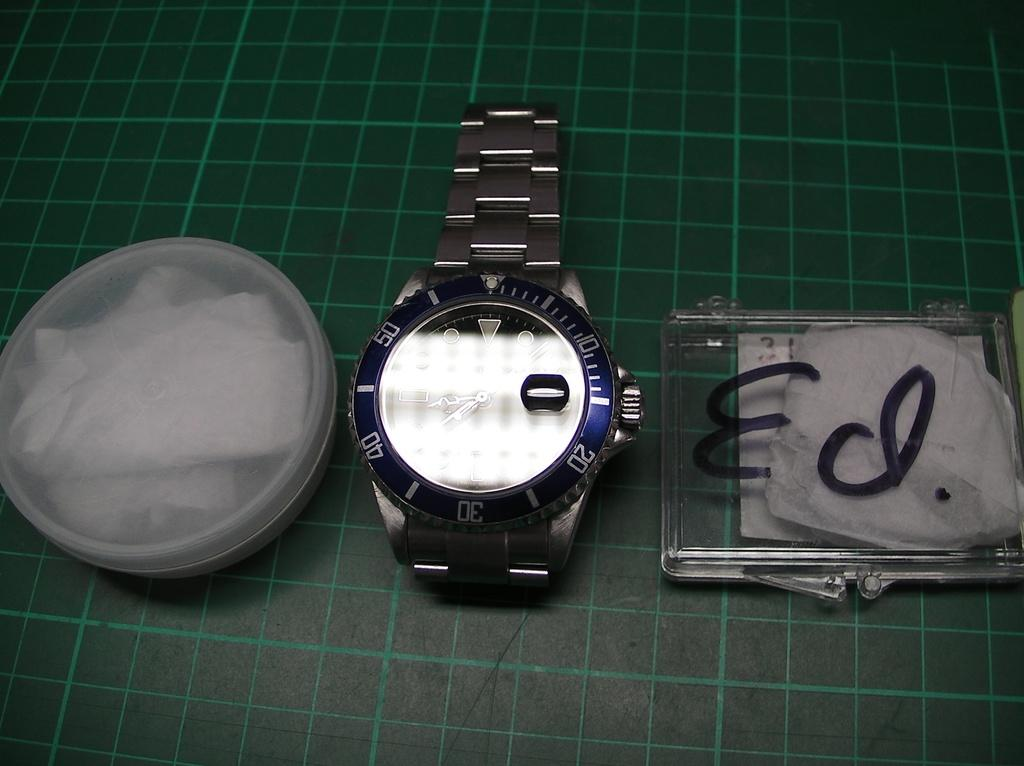<image>
Give a short and clear explanation of the subsequent image. A watch sits next to a clear case with the name Ed written on it in marker. 